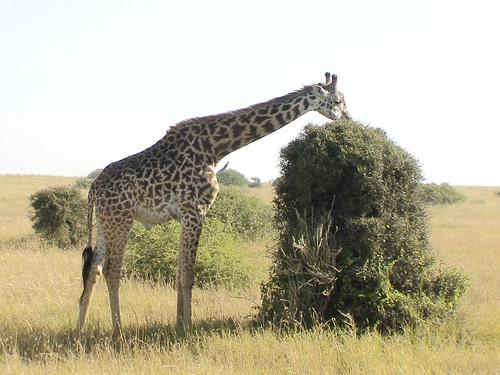Question: what day of the week is it?
Choices:
A. Tuesday.
B. Wednesday.
C. Monday.
D. Thursday.
Answer with the letter. Answer: C Question: what is the giraffe eating?
Choices:
A. Vegetation.
B. Leaves.
C. Lettuce.
D. My hat.
Answer with the letter. Answer: A Question: what time is it?
Choices:
A. Noon.
B. Midnight.
C. Three o'clock p.m.
D. Five o'clock p.m.
Answer with the letter. Answer: A Question: where was this scene taken?
Choices:
A. Asia.
B. Africa.
C. Europe.
D. India.
Answer with the letter. Answer: B Question: who took this photo?
Choices:
A. A woman.
B. A tourist.
C. A man.
D. A child.
Answer with the letter. Answer: B Question: how many giraffes are there?
Choices:
A. Two.
B. Four.
C. Nine.
D. One.
Answer with the letter. Answer: D 